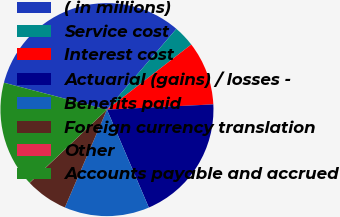Convert chart. <chart><loc_0><loc_0><loc_500><loc_500><pie_chart><fcel>( in millions)<fcel>Service cost<fcel>Interest cost<fcel>Actuarial (gains) / losses -<fcel>Benefits paid<fcel>Foreign currency translation<fcel>Other<fcel>Accounts payable and accrued<nl><fcel>32.23%<fcel>3.24%<fcel>9.68%<fcel>19.35%<fcel>12.9%<fcel>6.46%<fcel>0.02%<fcel>16.12%<nl></chart> 